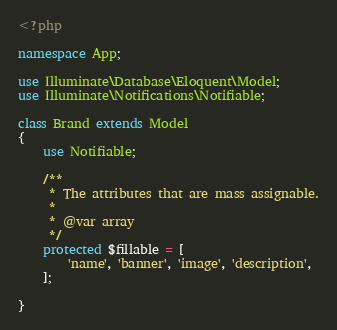Convert code to text. <code><loc_0><loc_0><loc_500><loc_500><_PHP_><?php

namespace App;

use Illuminate\Database\Eloquent\Model;
use Illuminate\Notifications\Notifiable;

class Brand extends Model
{
    use Notifiable;

    /**
     * The attributes that are mass assignable.
     *
     * @var array
     */
    protected $fillable = [
        'name', 'banner', 'image', 'description',
    ];

}
</code> 